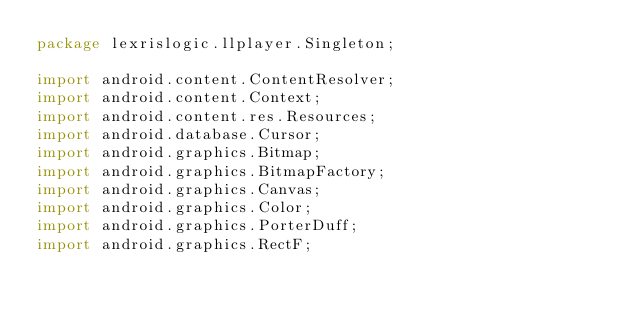Convert code to text. <code><loc_0><loc_0><loc_500><loc_500><_Java_>package lexrislogic.llplayer.Singleton;

import android.content.ContentResolver;
import android.content.Context;
import android.content.res.Resources;
import android.database.Cursor;
import android.graphics.Bitmap;
import android.graphics.BitmapFactory;
import android.graphics.Canvas;
import android.graphics.Color;
import android.graphics.PorterDuff;
import android.graphics.RectF;</code> 